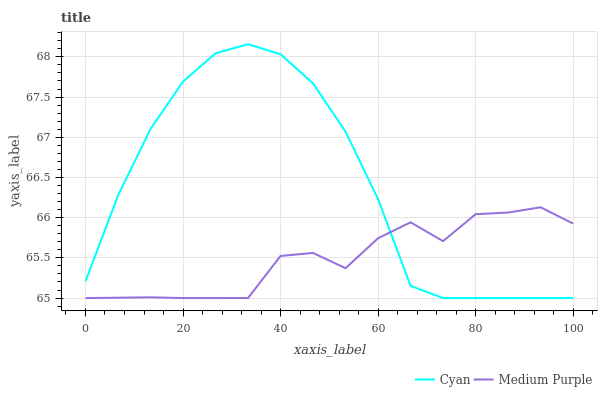Does Medium Purple have the minimum area under the curve?
Answer yes or no. Yes. Does Cyan have the maximum area under the curve?
Answer yes or no. Yes. Does Cyan have the minimum area under the curve?
Answer yes or no. No. Is Cyan the smoothest?
Answer yes or no. Yes. Is Medium Purple the roughest?
Answer yes or no. Yes. Is Cyan the roughest?
Answer yes or no. No. Does Cyan have the highest value?
Answer yes or no. Yes. Does Cyan intersect Medium Purple?
Answer yes or no. Yes. Is Cyan less than Medium Purple?
Answer yes or no. No. Is Cyan greater than Medium Purple?
Answer yes or no. No. 